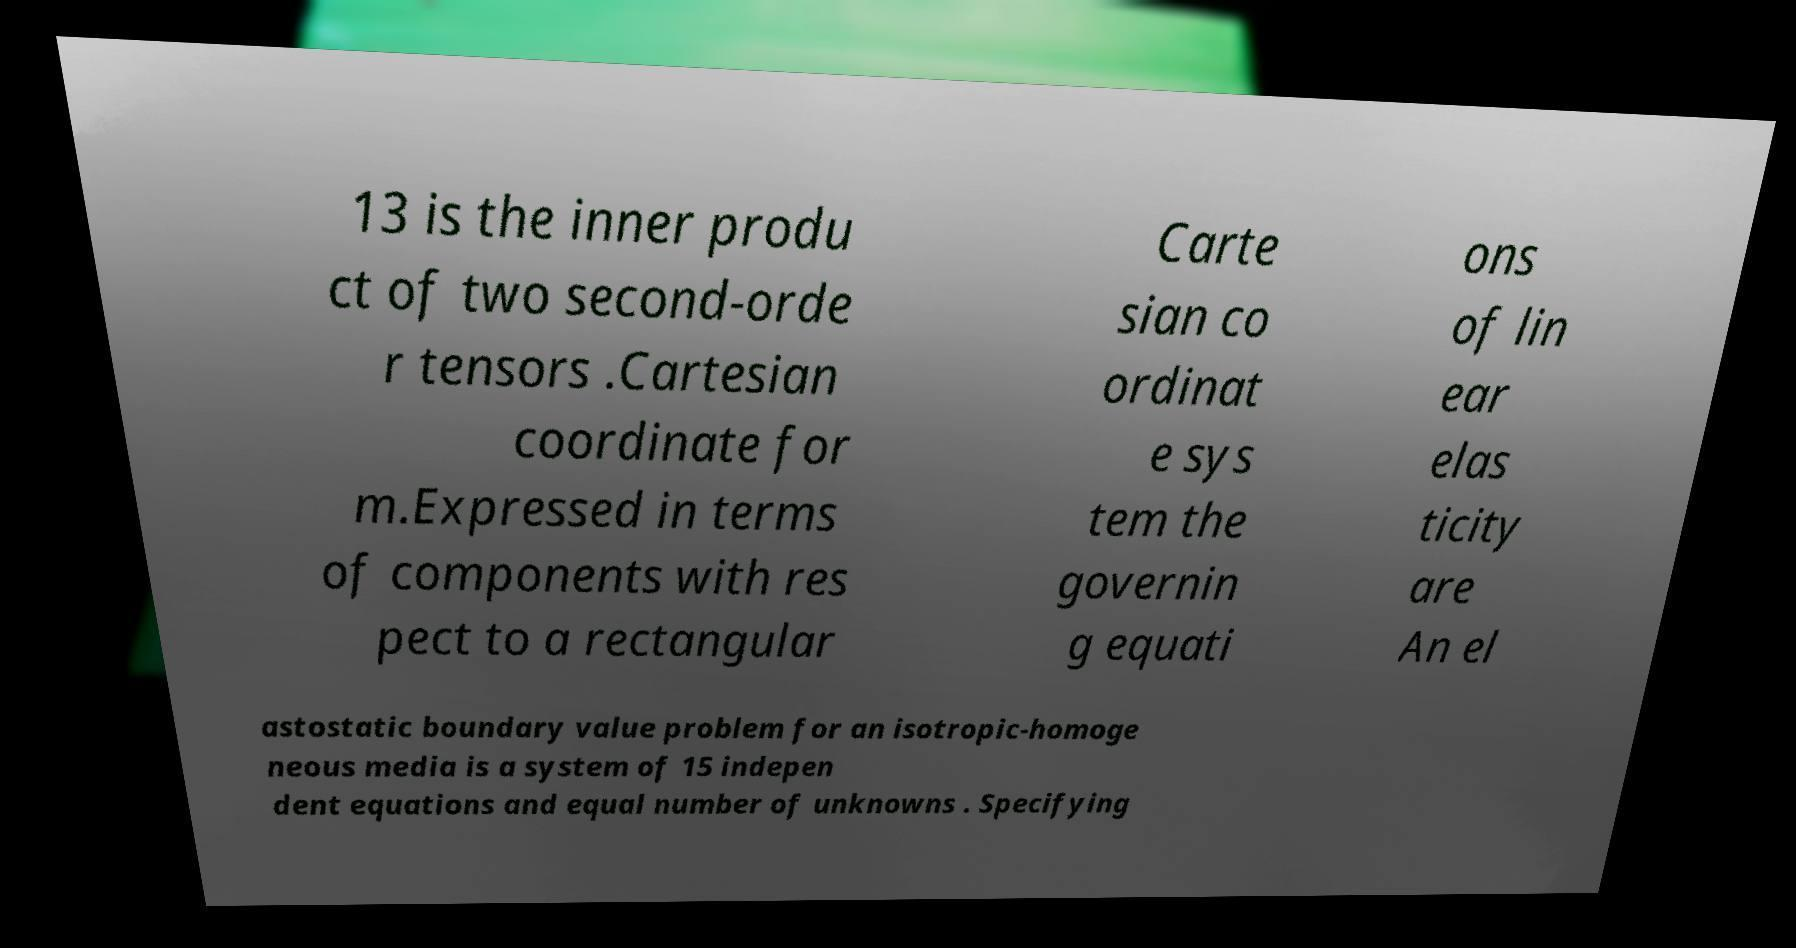There's text embedded in this image that I need extracted. Can you transcribe it verbatim? 13 is the inner produ ct of two second-orde r tensors .Cartesian coordinate for m.Expressed in terms of components with res pect to a rectangular Carte sian co ordinat e sys tem the governin g equati ons of lin ear elas ticity are An el astostatic boundary value problem for an isotropic-homoge neous media is a system of 15 indepen dent equations and equal number of unknowns . Specifying 